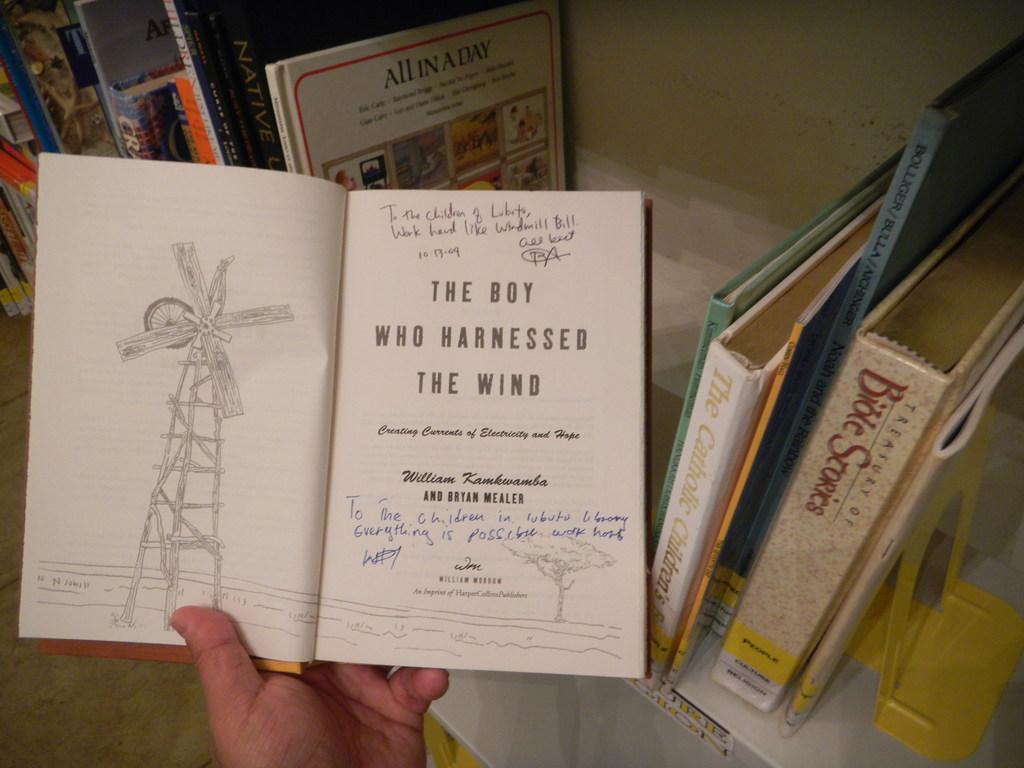What is the title of this book?
Give a very brief answer. The boy who harnessed the wind. Who is the author of the book?
Provide a succinct answer. William kamkwamba. 